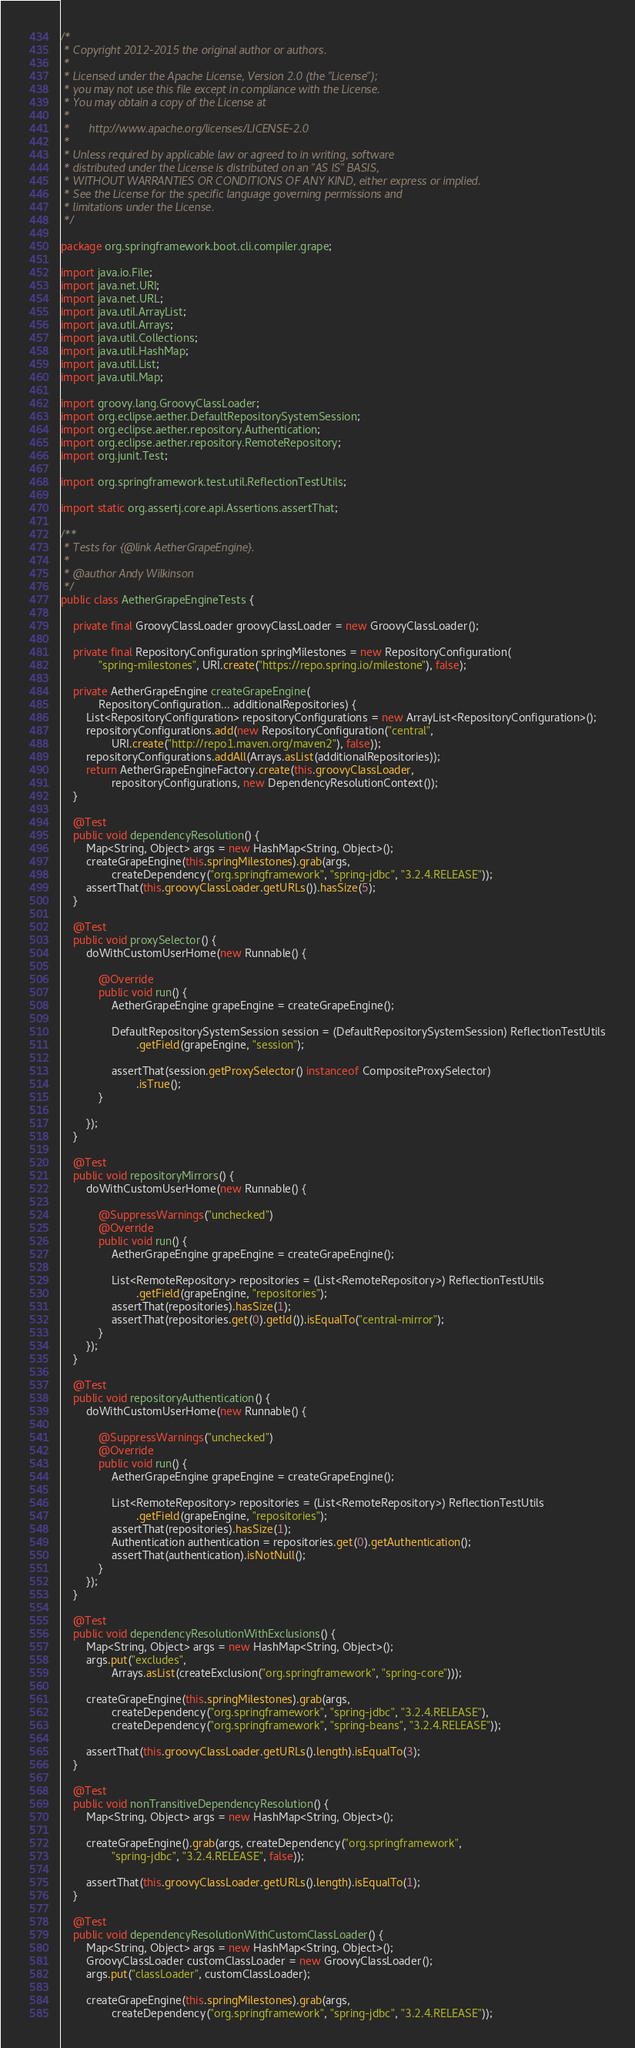Convert code to text. <code><loc_0><loc_0><loc_500><loc_500><_Java_>/*
 * Copyright 2012-2015 the original author or authors.
 *
 * Licensed under the Apache License, Version 2.0 (the "License");
 * you may not use this file except in compliance with the License.
 * You may obtain a copy of the License at
 *
 *      http://www.apache.org/licenses/LICENSE-2.0
 *
 * Unless required by applicable law or agreed to in writing, software
 * distributed under the License is distributed on an "AS IS" BASIS,
 * WITHOUT WARRANTIES OR CONDITIONS OF ANY KIND, either express or implied.
 * See the License for the specific language governing permissions and
 * limitations under the License.
 */

package org.springframework.boot.cli.compiler.grape;

import java.io.File;
import java.net.URI;
import java.net.URL;
import java.util.ArrayList;
import java.util.Arrays;
import java.util.Collections;
import java.util.HashMap;
import java.util.List;
import java.util.Map;

import groovy.lang.GroovyClassLoader;
import org.eclipse.aether.DefaultRepositorySystemSession;
import org.eclipse.aether.repository.Authentication;
import org.eclipse.aether.repository.RemoteRepository;
import org.junit.Test;

import org.springframework.test.util.ReflectionTestUtils;

import static org.assertj.core.api.Assertions.assertThat;

/**
 * Tests for {@link AetherGrapeEngine}.
 *
 * @author Andy Wilkinson
 */
public class AetherGrapeEngineTests {

	private final GroovyClassLoader groovyClassLoader = new GroovyClassLoader();

	private final RepositoryConfiguration springMilestones = new RepositoryConfiguration(
			"spring-milestones", URI.create("https://repo.spring.io/milestone"), false);

	private AetherGrapeEngine createGrapeEngine(
			RepositoryConfiguration... additionalRepositories) {
		List<RepositoryConfiguration> repositoryConfigurations = new ArrayList<RepositoryConfiguration>();
		repositoryConfigurations.add(new RepositoryConfiguration("central",
				URI.create("http://repo1.maven.org/maven2"), false));
		repositoryConfigurations.addAll(Arrays.asList(additionalRepositories));
		return AetherGrapeEngineFactory.create(this.groovyClassLoader,
				repositoryConfigurations, new DependencyResolutionContext());
	}

	@Test
	public void dependencyResolution() {
		Map<String, Object> args = new HashMap<String, Object>();
		createGrapeEngine(this.springMilestones).grab(args,
				createDependency("org.springframework", "spring-jdbc", "3.2.4.RELEASE"));
		assertThat(this.groovyClassLoader.getURLs()).hasSize(5);
	}

	@Test
	public void proxySelector() {
		doWithCustomUserHome(new Runnable() {

			@Override
			public void run() {
				AetherGrapeEngine grapeEngine = createGrapeEngine();

				DefaultRepositorySystemSession session = (DefaultRepositorySystemSession) ReflectionTestUtils
						.getField(grapeEngine, "session");

				assertThat(session.getProxySelector() instanceof CompositeProxySelector)
						.isTrue();
			}

		});
	}

	@Test
	public void repositoryMirrors() {
		doWithCustomUserHome(new Runnable() {

			@SuppressWarnings("unchecked")
			@Override
			public void run() {
				AetherGrapeEngine grapeEngine = createGrapeEngine();

				List<RemoteRepository> repositories = (List<RemoteRepository>) ReflectionTestUtils
						.getField(grapeEngine, "repositories");
				assertThat(repositories).hasSize(1);
				assertThat(repositories.get(0).getId()).isEqualTo("central-mirror");
			}
		});
	}

	@Test
	public void repositoryAuthentication() {
		doWithCustomUserHome(new Runnable() {

			@SuppressWarnings("unchecked")
			@Override
			public void run() {
				AetherGrapeEngine grapeEngine = createGrapeEngine();

				List<RemoteRepository> repositories = (List<RemoteRepository>) ReflectionTestUtils
						.getField(grapeEngine, "repositories");
				assertThat(repositories).hasSize(1);
				Authentication authentication = repositories.get(0).getAuthentication();
				assertThat(authentication).isNotNull();
			}
		});
	}

	@Test
	public void dependencyResolutionWithExclusions() {
		Map<String, Object> args = new HashMap<String, Object>();
		args.put("excludes",
				Arrays.asList(createExclusion("org.springframework", "spring-core")));

		createGrapeEngine(this.springMilestones).grab(args,
				createDependency("org.springframework", "spring-jdbc", "3.2.4.RELEASE"),
				createDependency("org.springframework", "spring-beans", "3.2.4.RELEASE"));

		assertThat(this.groovyClassLoader.getURLs().length).isEqualTo(3);
	}

	@Test
	public void nonTransitiveDependencyResolution() {
		Map<String, Object> args = new HashMap<String, Object>();

		createGrapeEngine().grab(args, createDependency("org.springframework",
				"spring-jdbc", "3.2.4.RELEASE", false));

		assertThat(this.groovyClassLoader.getURLs().length).isEqualTo(1);
	}

	@Test
	public void dependencyResolutionWithCustomClassLoader() {
		Map<String, Object> args = new HashMap<String, Object>();
		GroovyClassLoader customClassLoader = new GroovyClassLoader();
		args.put("classLoader", customClassLoader);

		createGrapeEngine(this.springMilestones).grab(args,
				createDependency("org.springframework", "spring-jdbc", "3.2.4.RELEASE"));
</code> 